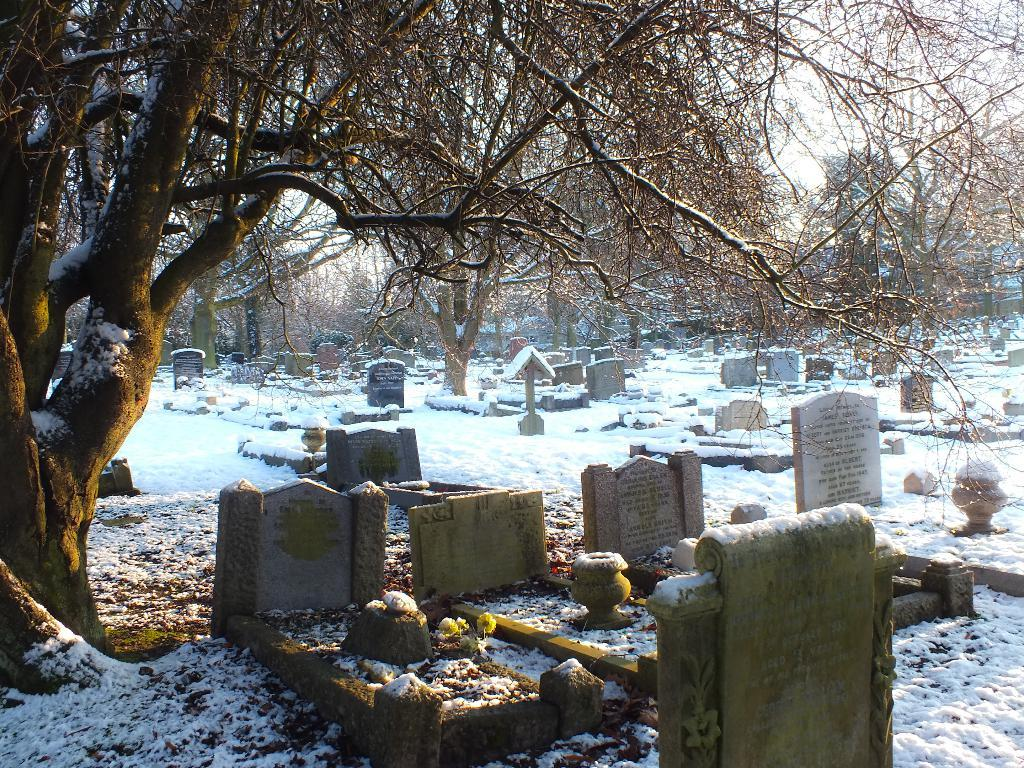What is the main setting of the image? There is a graveyard in the image. Can you describe any specific features in the image? There is a tree on the left side of the image. Where is the honey located in the image? There is no honey present in the image. Can you see any snakes slithering around the tree in the image? There are no snakes visible in the image. 